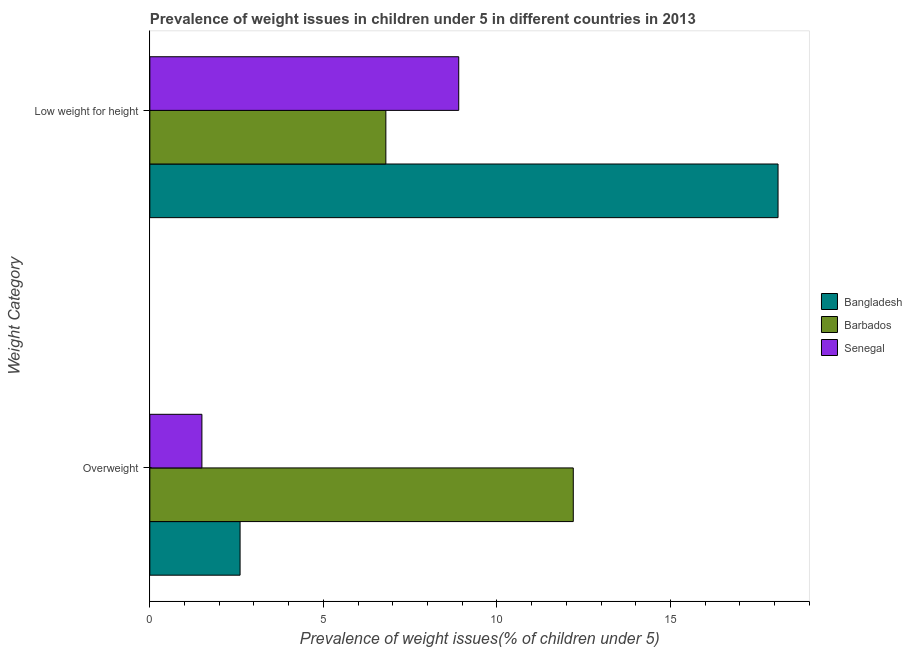How many groups of bars are there?
Provide a succinct answer. 2. Are the number of bars per tick equal to the number of legend labels?
Offer a terse response. Yes. Are the number of bars on each tick of the Y-axis equal?
Your answer should be very brief. Yes. How many bars are there on the 1st tick from the bottom?
Ensure brevity in your answer.  3. What is the label of the 2nd group of bars from the top?
Keep it short and to the point. Overweight. Across all countries, what is the maximum percentage of underweight children?
Ensure brevity in your answer.  18.1. Across all countries, what is the minimum percentage of underweight children?
Keep it short and to the point. 6.8. In which country was the percentage of overweight children minimum?
Offer a very short reply. Senegal. What is the total percentage of overweight children in the graph?
Your answer should be compact. 16.3. What is the difference between the percentage of underweight children in Barbados and that in Bangladesh?
Your response must be concise. -11.3. What is the difference between the percentage of underweight children in Barbados and the percentage of overweight children in Senegal?
Provide a succinct answer. 5.3. What is the average percentage of overweight children per country?
Keep it short and to the point. 5.43. What is the difference between the percentage of overweight children and percentage of underweight children in Barbados?
Give a very brief answer. 5.4. What is the ratio of the percentage of overweight children in Bangladesh to that in Senegal?
Offer a terse response. 1.73. Is the percentage of overweight children in Bangladesh less than that in Barbados?
Give a very brief answer. Yes. What does the 3rd bar from the top in Low weight for height represents?
Your answer should be compact. Bangladesh. What does the 1st bar from the bottom in Low weight for height represents?
Give a very brief answer. Bangladesh. How many bars are there?
Make the answer very short. 6. Are all the bars in the graph horizontal?
Provide a succinct answer. Yes. What is the difference between two consecutive major ticks on the X-axis?
Provide a short and direct response. 5. How many legend labels are there?
Your answer should be compact. 3. How are the legend labels stacked?
Your response must be concise. Vertical. What is the title of the graph?
Ensure brevity in your answer.  Prevalence of weight issues in children under 5 in different countries in 2013. Does "Dominica" appear as one of the legend labels in the graph?
Your answer should be very brief. No. What is the label or title of the X-axis?
Offer a very short reply. Prevalence of weight issues(% of children under 5). What is the label or title of the Y-axis?
Your response must be concise. Weight Category. What is the Prevalence of weight issues(% of children under 5) of Bangladesh in Overweight?
Offer a very short reply. 2.6. What is the Prevalence of weight issues(% of children under 5) in Bangladesh in Low weight for height?
Give a very brief answer. 18.1. What is the Prevalence of weight issues(% of children under 5) of Senegal in Low weight for height?
Your response must be concise. 8.9. Across all Weight Category, what is the maximum Prevalence of weight issues(% of children under 5) of Bangladesh?
Offer a terse response. 18.1. Across all Weight Category, what is the maximum Prevalence of weight issues(% of children under 5) of Senegal?
Make the answer very short. 8.9. Across all Weight Category, what is the minimum Prevalence of weight issues(% of children under 5) in Bangladesh?
Offer a terse response. 2.6. Across all Weight Category, what is the minimum Prevalence of weight issues(% of children under 5) of Barbados?
Your answer should be compact. 6.8. Across all Weight Category, what is the minimum Prevalence of weight issues(% of children under 5) of Senegal?
Provide a short and direct response. 1.5. What is the total Prevalence of weight issues(% of children under 5) in Bangladesh in the graph?
Make the answer very short. 20.7. What is the total Prevalence of weight issues(% of children under 5) of Senegal in the graph?
Your answer should be compact. 10.4. What is the difference between the Prevalence of weight issues(% of children under 5) in Bangladesh in Overweight and that in Low weight for height?
Keep it short and to the point. -15.5. What is the difference between the Prevalence of weight issues(% of children under 5) of Bangladesh in Overweight and the Prevalence of weight issues(% of children under 5) of Barbados in Low weight for height?
Provide a short and direct response. -4.2. What is the average Prevalence of weight issues(% of children under 5) of Bangladesh per Weight Category?
Provide a short and direct response. 10.35. What is the difference between the Prevalence of weight issues(% of children under 5) of Bangladesh and Prevalence of weight issues(% of children under 5) of Barbados in Overweight?
Offer a very short reply. -9.6. What is the difference between the Prevalence of weight issues(% of children under 5) in Barbados and Prevalence of weight issues(% of children under 5) in Senegal in Overweight?
Your answer should be compact. 10.7. What is the difference between the Prevalence of weight issues(% of children under 5) in Bangladesh and Prevalence of weight issues(% of children under 5) in Senegal in Low weight for height?
Your response must be concise. 9.2. What is the ratio of the Prevalence of weight issues(% of children under 5) in Bangladesh in Overweight to that in Low weight for height?
Your answer should be compact. 0.14. What is the ratio of the Prevalence of weight issues(% of children under 5) of Barbados in Overweight to that in Low weight for height?
Offer a very short reply. 1.79. What is the ratio of the Prevalence of weight issues(% of children under 5) in Senegal in Overweight to that in Low weight for height?
Provide a succinct answer. 0.17. What is the difference between the highest and the second highest Prevalence of weight issues(% of children under 5) in Barbados?
Offer a very short reply. 5.4. What is the difference between the highest and the lowest Prevalence of weight issues(% of children under 5) in Bangladesh?
Your answer should be compact. 15.5. What is the difference between the highest and the lowest Prevalence of weight issues(% of children under 5) in Senegal?
Offer a very short reply. 7.4. 